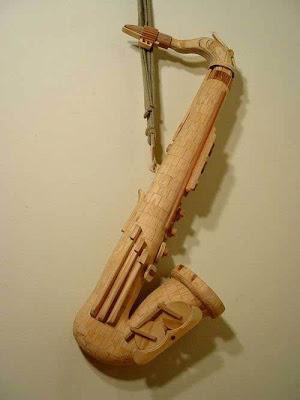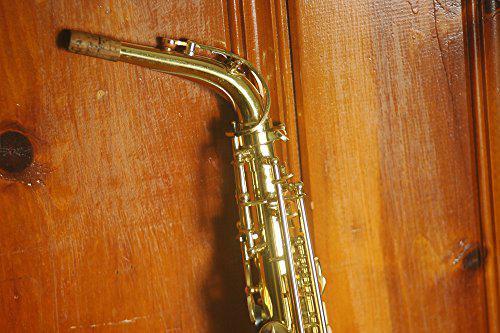The first image is the image on the left, the second image is the image on the right. Evaluate the accuracy of this statement regarding the images: "One of images contains a saxophone with wood in the background.". Is it true? Answer yes or no. Yes. 